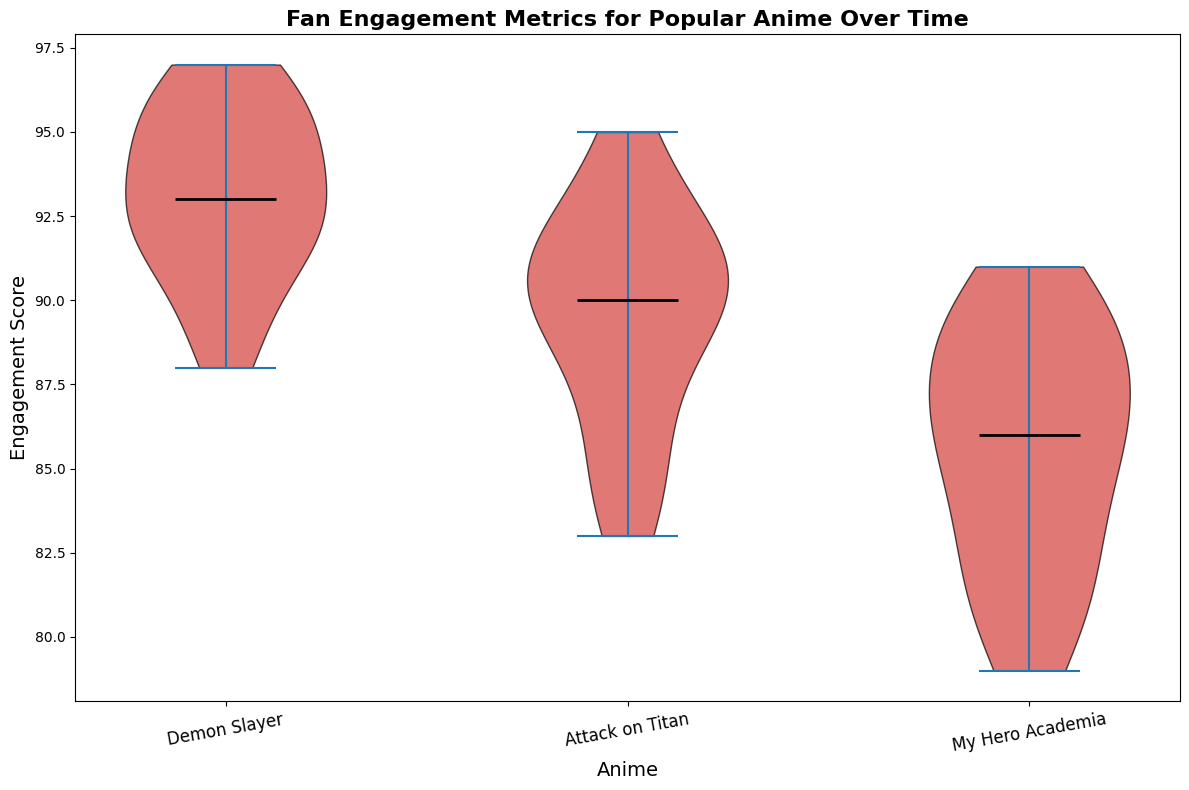What’s the median Engagement Score for Demon Slayer? The violin plot shows that the median is represented by a black line within the violin shape of each anime category. For Demon Slayer, this line is at the 94 mark.
Answer: 94 Which anime has the highest median engagement score? By looking at the black median lines in each of the violins for each anime, we see that Demon Slayer’s median line is higher than those of Attack on Titan and My Hero Academia.
Answer: Demon Slayer How does the range of engagement scores compare between Demon Slayer and My Hero Academia? For Demon Slayer, the range (difference between the highest and lowest points of its violin) is from approximately 88 to 97. For My Hero Academia, the range is from about 79 to 91. Thus, Demon Slayer has a wider range of engagement scores.
Answer: Demon Slayer has a wider range Which anime has the smallest range of engagement scores? By comparing the width of the violins horizontally, the narrowest range can be found in Attack on Titan, which spans from about 83 to 95.
Answer: Attack on Titan If you had to rank the animes by their median engagement scores, what would the order be? By comparing the black median lines, the order from highest to lowest is: Demon Slayer, Attack on Titan, and then My Hero Academia.
Answer: 1. Demon Slayer 2. Attack on Titan 3. My Hero Academia Is there any anime showing a significant number of outliers, or are there no outliers visible in the plot? Outliers are typically displayed as individual points outside of the main violin shape. Observing the plot, none are indicated, meaning there are no significant outliers.
Answer: No outliers visible Compare the density of high engagement scores (above 90) for all three animes. The density (thickness) of the violins above the engagement score of 90 indicates how frequently these high scores occur. Demon Slayer shows a dense region above 90, meaning many weeks had high scores, whereas Attack on Titan and My Hero Academia show less density above 90 compared to Demon Slayer.
Answer: Demon Slayer has the highest density above 90 Are the engagement scores for My Hero Academia more spread out or concentrated compared to Attack on Titan? The shape of the violin for My Hero Academia shows it is wider, indicating more spread out data. Attack on Titan’s violin is narrower, indicating its scores are more concentrated.
Answer: More spread out Which anime shows the highest variance in engagement scores? Variance relates to the spread of the engagement scores in each violin. Demon Slayer's violin plot spans a larger vertical range compared to others, indicating a higher variance in its engagement scores.
Answer: Demon Slayer 